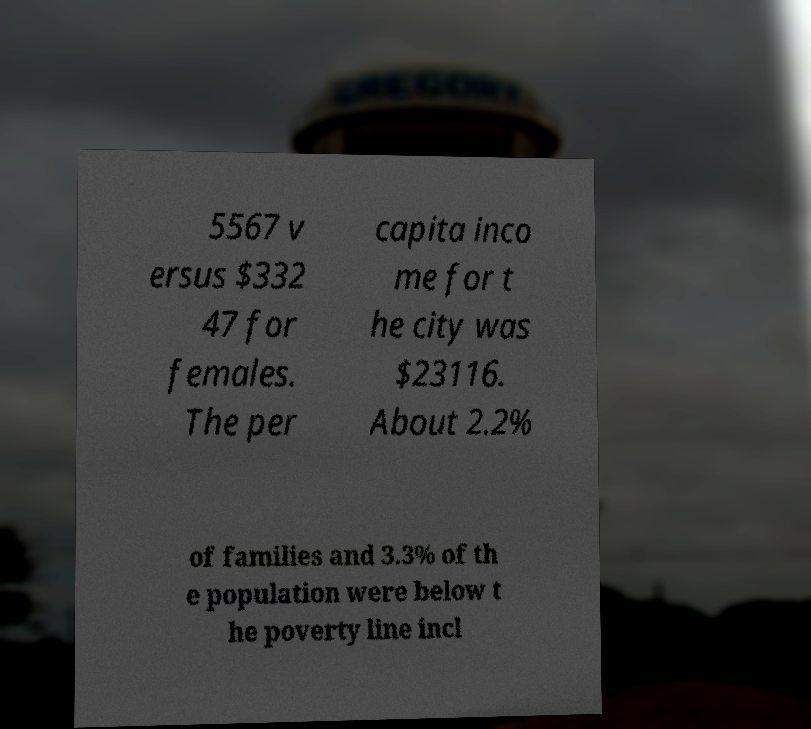Please identify and transcribe the text found in this image. 5567 v ersus $332 47 for females. The per capita inco me for t he city was $23116. About 2.2% of families and 3.3% of th e population were below t he poverty line incl 